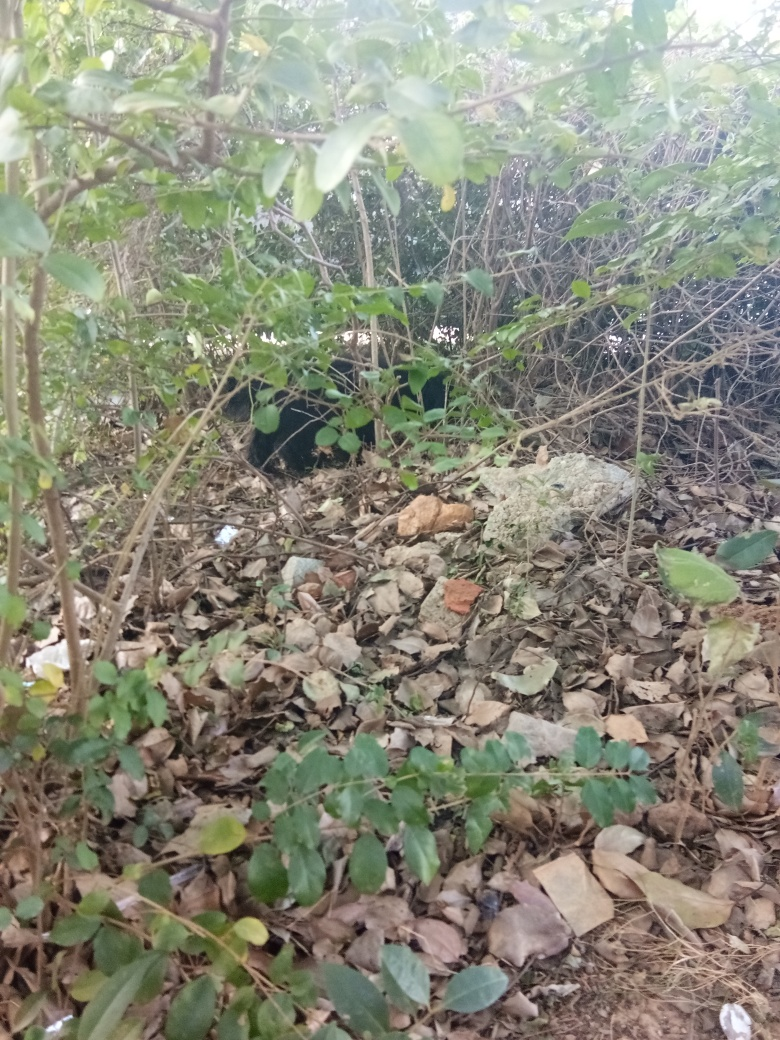Can you suggest how this image might be improved? To improve this image, one could focus on a specific subject to create a focal point, like zooming in on a particularly vibrant leaf or arranging the natural elements more artistically. Enhancing the contrast and sharpness could also bring more detail to the foreground, and choosing a time of day with better lighting conditions could improve the overall feel of the photo. 